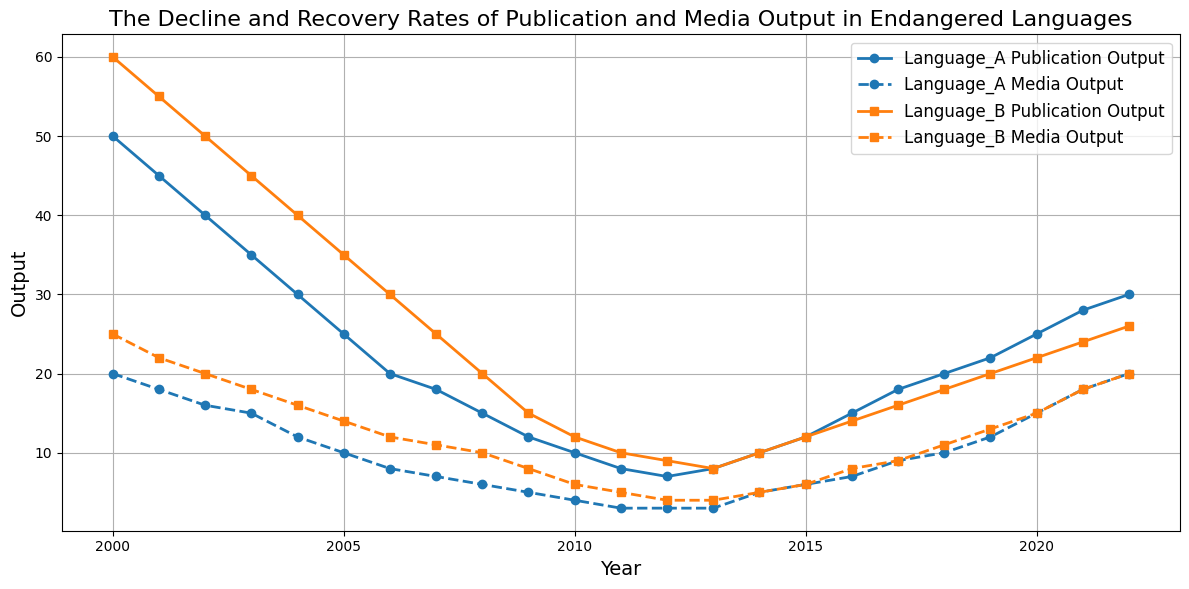What year did Language A reach its lowest publication output? Observe the line for 'Language A Publication Output' and identify the year where it drops to its lowest point. The lowest point occurs at 2012.
Answer: 2012 How much did the publication output of Language B increase from 2010 to 2022? Look at the 'Language B Publication Output' in 2010, which is 12, and in 2022, which is 26. Subtract the value in 2010 from the value in 2022: 26 - 12 = 14.
Answer: 14 Between 2000 and 2010, which language experienced a greater decline in media output? Compare the starting and ending points of the 'Media Output' lines for both languages. Language A goes from 20 to 4, a decline of 16, and Language B goes from 25 to 6, a decline of 19.
Answer: Language B In which year did both languages have the same media output? Find the points where the lines for 'Language A Media Output' and 'Language B Media Output' intersect. The intersection occurs at 2022 with both having media output of 20.
Answer: 2022 What was the percentage increase in media output for Language A from 2011 to 2022? Media output for Language A in 2011 is 3 and in 2022 is 20. Calculate the percentage increase: ((20 - 3) / 3) * 100 = 566.67%.
Answer: 566.67% What is the average publication output for Language A from 2017 to 2022? Add the publication outputs for Language A from 2017 to 2022 (18 + 20 + 22 + 25 + 28 + 30) and divide by the number of years, 6: (18 + 20 + 22 + 25 + 28 + 30) / 6 = 143 / 6 ≈ 23.83.
Answer: 23.83 Which year marks the beginning of recovery for publication output in Language A? Identify the year after the decline where 'Language A Publication Output' starts increasing. This occurs after 2012.
Answer: 2013 In 2018, which language had a higher publication output, and by how much? Compare the publication outputs for both languages in 2018. Language A has 20 and Language B has 18. Subtract to find the difference: 20 - 18 = 2.
Answer: Language A by 2 